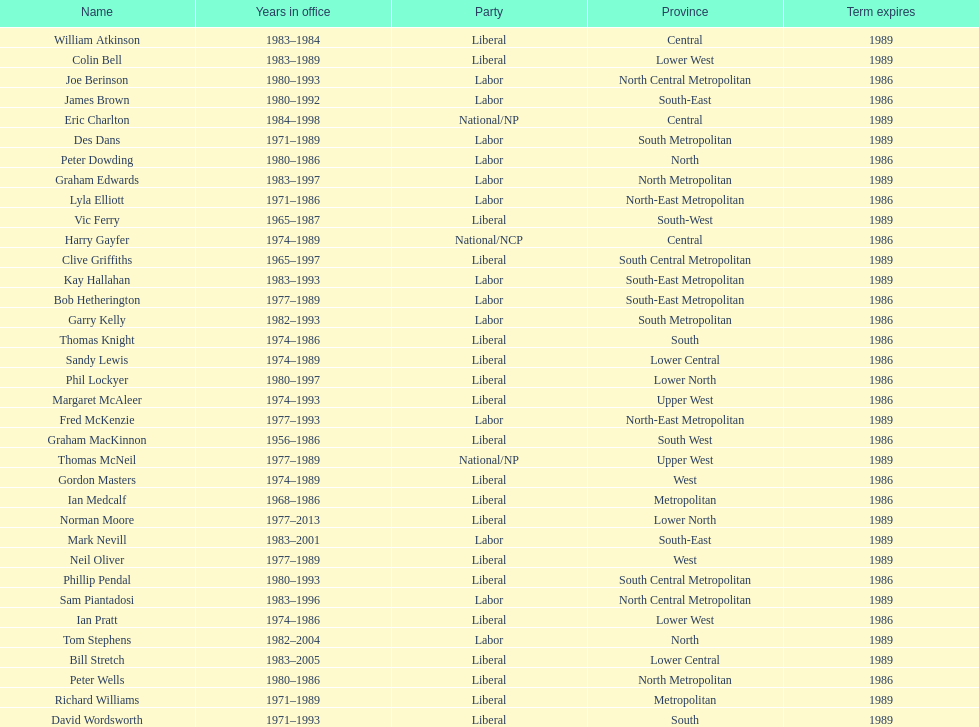What is the number of people in the liberal party? 19. 